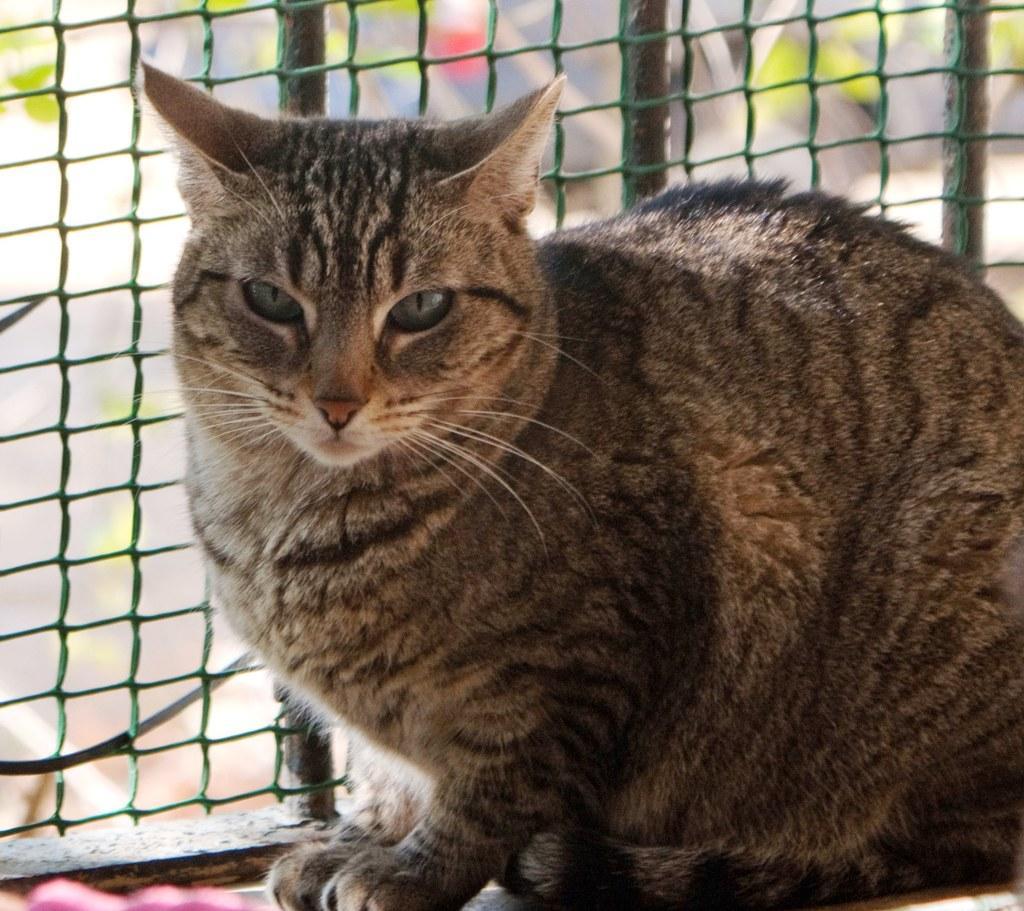Could you give a brief overview of what you see in this image? In this image we can see a cat. Behind the cat fencing is there. 